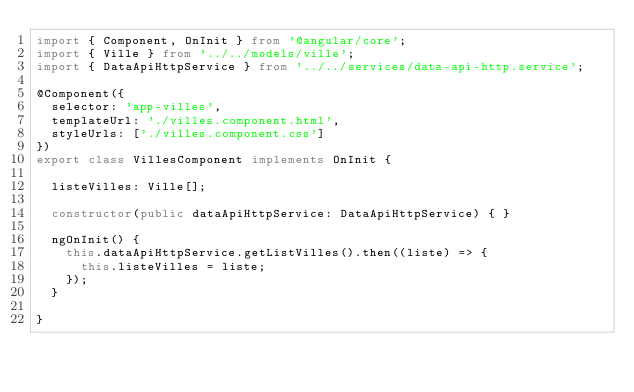<code> <loc_0><loc_0><loc_500><loc_500><_TypeScript_>import { Component, OnInit } from '@angular/core';
import { Ville } from '../../models/ville';
import { DataApiHttpService } from '../../services/data-api-http.service';

@Component({
  selector: 'app-villes',
  templateUrl: './villes.component.html',
  styleUrls: ['./villes.component.css']
})
export class VillesComponent implements OnInit {

  listeVilles: Ville[];

  constructor(public dataApiHttpService: DataApiHttpService) { }

  ngOnInit() {
    this.dataApiHttpService.getListVilles().then((liste) => {
      this.listeVilles = liste;
    });
  }

}
</code> 